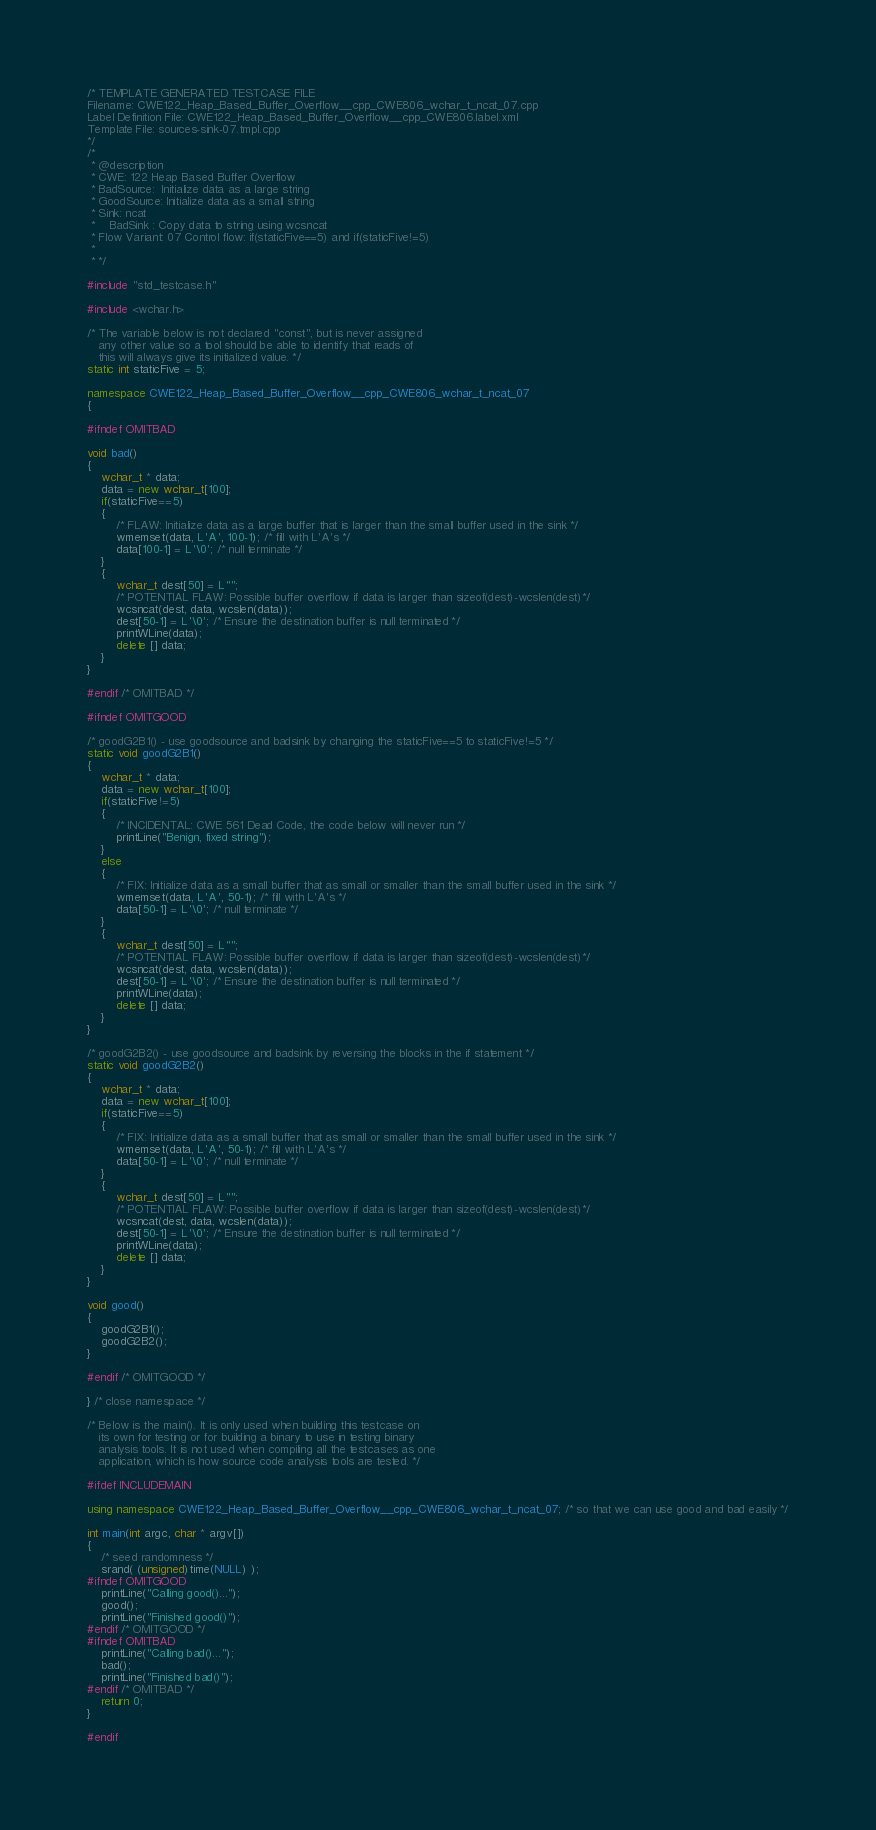<code> <loc_0><loc_0><loc_500><loc_500><_C++_>/* TEMPLATE GENERATED TESTCASE FILE
Filename: CWE122_Heap_Based_Buffer_Overflow__cpp_CWE806_wchar_t_ncat_07.cpp
Label Definition File: CWE122_Heap_Based_Buffer_Overflow__cpp_CWE806.label.xml
Template File: sources-sink-07.tmpl.cpp
*/
/*
 * @description
 * CWE: 122 Heap Based Buffer Overflow
 * BadSource:  Initialize data as a large string
 * GoodSource: Initialize data as a small string
 * Sink: ncat
 *    BadSink : Copy data to string using wcsncat
 * Flow Variant: 07 Control flow: if(staticFive==5) and if(staticFive!=5)
 *
 * */

#include "std_testcase.h"

#include <wchar.h>

/* The variable below is not declared "const", but is never assigned
   any other value so a tool should be able to identify that reads of
   this will always give its initialized value. */
static int staticFive = 5;

namespace CWE122_Heap_Based_Buffer_Overflow__cpp_CWE806_wchar_t_ncat_07
{

#ifndef OMITBAD

void bad()
{
    wchar_t * data;
    data = new wchar_t[100];
    if(staticFive==5)
    {
        /* FLAW: Initialize data as a large buffer that is larger than the small buffer used in the sink */
        wmemset(data, L'A', 100-1); /* fill with L'A's */
        data[100-1] = L'\0'; /* null terminate */
    }
    {
        wchar_t dest[50] = L"";
        /* POTENTIAL FLAW: Possible buffer overflow if data is larger than sizeof(dest)-wcslen(dest)*/
        wcsncat(dest, data, wcslen(data));
        dest[50-1] = L'\0'; /* Ensure the destination buffer is null terminated */
        printWLine(data);
        delete [] data;
    }
}

#endif /* OMITBAD */

#ifndef OMITGOOD

/* goodG2B1() - use goodsource and badsink by changing the staticFive==5 to staticFive!=5 */
static void goodG2B1()
{
    wchar_t * data;
    data = new wchar_t[100];
    if(staticFive!=5)
    {
        /* INCIDENTAL: CWE 561 Dead Code, the code below will never run */
        printLine("Benign, fixed string");
    }
    else
    {
        /* FIX: Initialize data as a small buffer that as small or smaller than the small buffer used in the sink */
        wmemset(data, L'A', 50-1); /* fill with L'A's */
        data[50-1] = L'\0'; /* null terminate */
    }
    {
        wchar_t dest[50] = L"";
        /* POTENTIAL FLAW: Possible buffer overflow if data is larger than sizeof(dest)-wcslen(dest)*/
        wcsncat(dest, data, wcslen(data));
        dest[50-1] = L'\0'; /* Ensure the destination buffer is null terminated */
        printWLine(data);
        delete [] data;
    }
}

/* goodG2B2() - use goodsource and badsink by reversing the blocks in the if statement */
static void goodG2B2()
{
    wchar_t * data;
    data = new wchar_t[100];
    if(staticFive==5)
    {
        /* FIX: Initialize data as a small buffer that as small or smaller than the small buffer used in the sink */
        wmemset(data, L'A', 50-1); /* fill with L'A's */
        data[50-1] = L'\0'; /* null terminate */
    }
    {
        wchar_t dest[50] = L"";
        /* POTENTIAL FLAW: Possible buffer overflow if data is larger than sizeof(dest)-wcslen(dest)*/
        wcsncat(dest, data, wcslen(data));
        dest[50-1] = L'\0'; /* Ensure the destination buffer is null terminated */
        printWLine(data);
        delete [] data;
    }
}

void good()
{
    goodG2B1();
    goodG2B2();
}

#endif /* OMITGOOD */

} /* close namespace */

/* Below is the main(). It is only used when building this testcase on
   its own for testing or for building a binary to use in testing binary
   analysis tools. It is not used when compiling all the testcases as one
   application, which is how source code analysis tools are tested. */

#ifdef INCLUDEMAIN

using namespace CWE122_Heap_Based_Buffer_Overflow__cpp_CWE806_wchar_t_ncat_07; /* so that we can use good and bad easily */

int main(int argc, char * argv[])
{
    /* seed randomness */
    srand( (unsigned)time(NULL) );
#ifndef OMITGOOD
    printLine("Calling good()...");
    good();
    printLine("Finished good()");
#endif /* OMITGOOD */
#ifndef OMITBAD
    printLine("Calling bad()...");
    bad();
    printLine("Finished bad()");
#endif /* OMITBAD */
    return 0;
}

#endif
</code> 